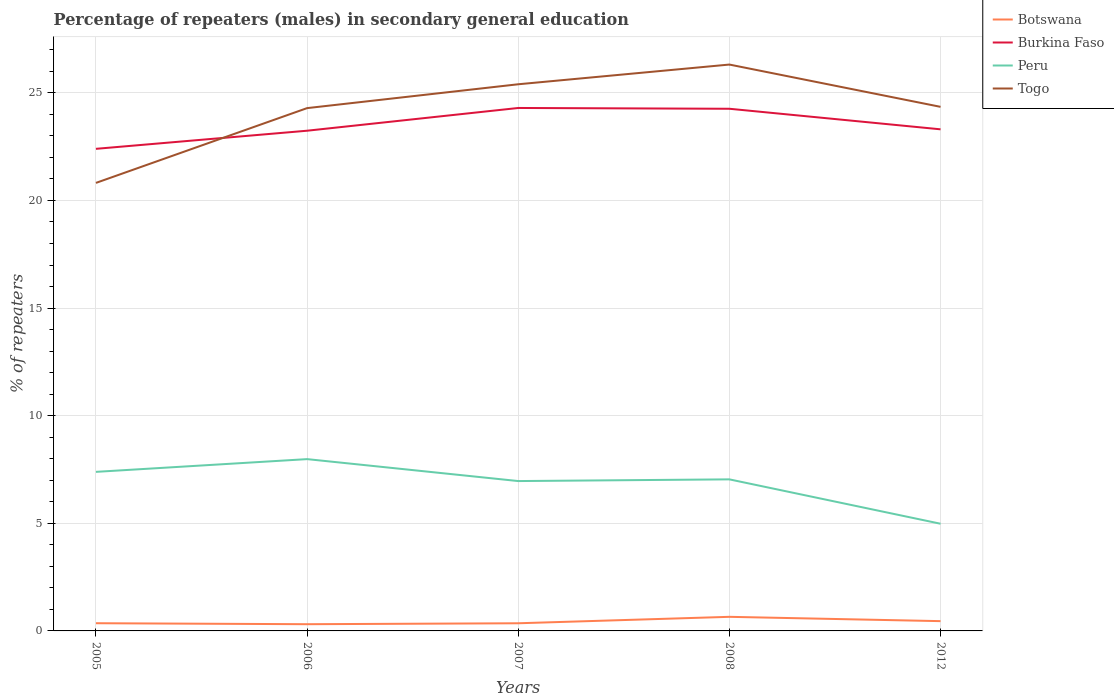Does the line corresponding to Botswana intersect with the line corresponding to Togo?
Offer a terse response. No. Is the number of lines equal to the number of legend labels?
Keep it short and to the point. Yes. Across all years, what is the maximum percentage of male repeaters in Burkina Faso?
Keep it short and to the point. 22.4. What is the total percentage of male repeaters in Togo in the graph?
Ensure brevity in your answer.  -3.53. What is the difference between the highest and the second highest percentage of male repeaters in Burkina Faso?
Provide a succinct answer. 1.9. What is the difference between the highest and the lowest percentage of male repeaters in Togo?
Provide a succinct answer. 4. How many years are there in the graph?
Provide a succinct answer. 5. Does the graph contain any zero values?
Ensure brevity in your answer.  No. What is the title of the graph?
Your answer should be very brief. Percentage of repeaters (males) in secondary general education. Does "Fragile and conflict affected situations" appear as one of the legend labels in the graph?
Give a very brief answer. No. What is the label or title of the X-axis?
Your response must be concise. Years. What is the label or title of the Y-axis?
Your answer should be very brief. % of repeaters. What is the % of repeaters of Botswana in 2005?
Provide a succinct answer. 0.36. What is the % of repeaters in Burkina Faso in 2005?
Make the answer very short. 22.4. What is the % of repeaters of Peru in 2005?
Ensure brevity in your answer.  7.39. What is the % of repeaters of Togo in 2005?
Keep it short and to the point. 20.82. What is the % of repeaters in Botswana in 2006?
Your answer should be compact. 0.31. What is the % of repeaters in Burkina Faso in 2006?
Your answer should be compact. 23.24. What is the % of repeaters in Peru in 2006?
Your response must be concise. 7.98. What is the % of repeaters in Togo in 2006?
Make the answer very short. 24.29. What is the % of repeaters of Botswana in 2007?
Your response must be concise. 0.36. What is the % of repeaters in Burkina Faso in 2007?
Make the answer very short. 24.3. What is the % of repeaters of Peru in 2007?
Make the answer very short. 6.96. What is the % of repeaters of Togo in 2007?
Offer a terse response. 25.4. What is the % of repeaters of Botswana in 2008?
Provide a succinct answer. 0.65. What is the % of repeaters in Burkina Faso in 2008?
Make the answer very short. 24.26. What is the % of repeaters in Peru in 2008?
Provide a succinct answer. 7.04. What is the % of repeaters of Togo in 2008?
Give a very brief answer. 26.31. What is the % of repeaters in Botswana in 2012?
Give a very brief answer. 0.45. What is the % of repeaters in Burkina Faso in 2012?
Your answer should be very brief. 23.3. What is the % of repeaters in Peru in 2012?
Give a very brief answer. 4.98. What is the % of repeaters of Togo in 2012?
Your response must be concise. 24.35. Across all years, what is the maximum % of repeaters in Botswana?
Provide a succinct answer. 0.65. Across all years, what is the maximum % of repeaters of Burkina Faso?
Ensure brevity in your answer.  24.3. Across all years, what is the maximum % of repeaters in Peru?
Your answer should be very brief. 7.98. Across all years, what is the maximum % of repeaters of Togo?
Make the answer very short. 26.31. Across all years, what is the minimum % of repeaters of Botswana?
Provide a succinct answer. 0.31. Across all years, what is the minimum % of repeaters in Burkina Faso?
Your answer should be compact. 22.4. Across all years, what is the minimum % of repeaters of Peru?
Your answer should be very brief. 4.98. Across all years, what is the minimum % of repeaters in Togo?
Offer a very short reply. 20.82. What is the total % of repeaters in Botswana in the graph?
Your response must be concise. 2.14. What is the total % of repeaters of Burkina Faso in the graph?
Keep it short and to the point. 117.5. What is the total % of repeaters in Peru in the graph?
Ensure brevity in your answer.  34.36. What is the total % of repeaters of Togo in the graph?
Offer a terse response. 121.17. What is the difference between the % of repeaters in Botswana in 2005 and that in 2006?
Your response must be concise. 0.05. What is the difference between the % of repeaters in Burkina Faso in 2005 and that in 2006?
Offer a terse response. -0.84. What is the difference between the % of repeaters in Peru in 2005 and that in 2006?
Your answer should be very brief. -0.59. What is the difference between the % of repeaters in Togo in 2005 and that in 2006?
Ensure brevity in your answer.  -3.47. What is the difference between the % of repeaters of Botswana in 2005 and that in 2007?
Provide a succinct answer. 0. What is the difference between the % of repeaters in Burkina Faso in 2005 and that in 2007?
Keep it short and to the point. -1.9. What is the difference between the % of repeaters in Peru in 2005 and that in 2007?
Your response must be concise. 0.43. What is the difference between the % of repeaters of Togo in 2005 and that in 2007?
Offer a terse response. -4.58. What is the difference between the % of repeaters of Botswana in 2005 and that in 2008?
Ensure brevity in your answer.  -0.3. What is the difference between the % of repeaters in Burkina Faso in 2005 and that in 2008?
Your response must be concise. -1.86. What is the difference between the % of repeaters in Peru in 2005 and that in 2008?
Your response must be concise. 0.35. What is the difference between the % of repeaters in Togo in 2005 and that in 2008?
Offer a very short reply. -5.5. What is the difference between the % of repeaters of Botswana in 2005 and that in 2012?
Offer a very short reply. -0.1. What is the difference between the % of repeaters in Burkina Faso in 2005 and that in 2012?
Offer a terse response. -0.91. What is the difference between the % of repeaters of Peru in 2005 and that in 2012?
Provide a short and direct response. 2.41. What is the difference between the % of repeaters of Togo in 2005 and that in 2012?
Provide a short and direct response. -3.53. What is the difference between the % of repeaters of Botswana in 2006 and that in 2007?
Your answer should be compact. -0.04. What is the difference between the % of repeaters in Burkina Faso in 2006 and that in 2007?
Provide a succinct answer. -1.06. What is the difference between the % of repeaters of Peru in 2006 and that in 2007?
Your answer should be very brief. 1.02. What is the difference between the % of repeaters of Togo in 2006 and that in 2007?
Ensure brevity in your answer.  -1.11. What is the difference between the % of repeaters in Botswana in 2006 and that in 2008?
Your response must be concise. -0.34. What is the difference between the % of repeaters of Burkina Faso in 2006 and that in 2008?
Ensure brevity in your answer.  -1.02. What is the difference between the % of repeaters of Peru in 2006 and that in 2008?
Make the answer very short. 0.94. What is the difference between the % of repeaters in Togo in 2006 and that in 2008?
Offer a terse response. -2.02. What is the difference between the % of repeaters of Botswana in 2006 and that in 2012?
Provide a succinct answer. -0.14. What is the difference between the % of repeaters in Burkina Faso in 2006 and that in 2012?
Keep it short and to the point. -0.06. What is the difference between the % of repeaters in Peru in 2006 and that in 2012?
Your answer should be compact. 3. What is the difference between the % of repeaters in Togo in 2006 and that in 2012?
Provide a short and direct response. -0.06. What is the difference between the % of repeaters of Botswana in 2007 and that in 2008?
Your response must be concise. -0.3. What is the difference between the % of repeaters of Burkina Faso in 2007 and that in 2008?
Ensure brevity in your answer.  0.04. What is the difference between the % of repeaters in Peru in 2007 and that in 2008?
Offer a very short reply. -0.08. What is the difference between the % of repeaters in Togo in 2007 and that in 2008?
Your response must be concise. -0.92. What is the difference between the % of repeaters of Botswana in 2007 and that in 2012?
Offer a terse response. -0.1. What is the difference between the % of repeaters in Burkina Faso in 2007 and that in 2012?
Offer a terse response. 0.99. What is the difference between the % of repeaters in Peru in 2007 and that in 2012?
Provide a short and direct response. 1.98. What is the difference between the % of repeaters in Togo in 2007 and that in 2012?
Make the answer very short. 1.05. What is the difference between the % of repeaters in Botswana in 2008 and that in 2012?
Your response must be concise. 0.2. What is the difference between the % of repeaters in Burkina Faso in 2008 and that in 2012?
Provide a succinct answer. 0.96. What is the difference between the % of repeaters in Peru in 2008 and that in 2012?
Provide a short and direct response. 2.06. What is the difference between the % of repeaters of Togo in 2008 and that in 2012?
Provide a short and direct response. 1.96. What is the difference between the % of repeaters of Botswana in 2005 and the % of repeaters of Burkina Faso in 2006?
Offer a very short reply. -22.88. What is the difference between the % of repeaters in Botswana in 2005 and the % of repeaters in Peru in 2006?
Your response must be concise. -7.62. What is the difference between the % of repeaters in Botswana in 2005 and the % of repeaters in Togo in 2006?
Your answer should be very brief. -23.93. What is the difference between the % of repeaters of Burkina Faso in 2005 and the % of repeaters of Peru in 2006?
Give a very brief answer. 14.42. What is the difference between the % of repeaters in Burkina Faso in 2005 and the % of repeaters in Togo in 2006?
Provide a succinct answer. -1.89. What is the difference between the % of repeaters in Peru in 2005 and the % of repeaters in Togo in 2006?
Give a very brief answer. -16.9. What is the difference between the % of repeaters of Botswana in 2005 and the % of repeaters of Burkina Faso in 2007?
Your answer should be compact. -23.94. What is the difference between the % of repeaters in Botswana in 2005 and the % of repeaters in Peru in 2007?
Make the answer very short. -6.6. What is the difference between the % of repeaters in Botswana in 2005 and the % of repeaters in Togo in 2007?
Your response must be concise. -25.04. What is the difference between the % of repeaters in Burkina Faso in 2005 and the % of repeaters in Peru in 2007?
Keep it short and to the point. 15.44. What is the difference between the % of repeaters of Burkina Faso in 2005 and the % of repeaters of Togo in 2007?
Your response must be concise. -3. What is the difference between the % of repeaters of Peru in 2005 and the % of repeaters of Togo in 2007?
Offer a very short reply. -18.01. What is the difference between the % of repeaters in Botswana in 2005 and the % of repeaters in Burkina Faso in 2008?
Keep it short and to the point. -23.9. What is the difference between the % of repeaters of Botswana in 2005 and the % of repeaters of Peru in 2008?
Give a very brief answer. -6.68. What is the difference between the % of repeaters in Botswana in 2005 and the % of repeaters in Togo in 2008?
Offer a terse response. -25.96. What is the difference between the % of repeaters of Burkina Faso in 2005 and the % of repeaters of Peru in 2008?
Your response must be concise. 15.36. What is the difference between the % of repeaters of Burkina Faso in 2005 and the % of repeaters of Togo in 2008?
Ensure brevity in your answer.  -3.92. What is the difference between the % of repeaters of Peru in 2005 and the % of repeaters of Togo in 2008?
Provide a succinct answer. -18.92. What is the difference between the % of repeaters of Botswana in 2005 and the % of repeaters of Burkina Faso in 2012?
Your answer should be very brief. -22.95. What is the difference between the % of repeaters in Botswana in 2005 and the % of repeaters in Peru in 2012?
Your response must be concise. -4.62. What is the difference between the % of repeaters in Botswana in 2005 and the % of repeaters in Togo in 2012?
Your answer should be compact. -23.99. What is the difference between the % of repeaters in Burkina Faso in 2005 and the % of repeaters in Peru in 2012?
Ensure brevity in your answer.  17.42. What is the difference between the % of repeaters in Burkina Faso in 2005 and the % of repeaters in Togo in 2012?
Keep it short and to the point. -1.95. What is the difference between the % of repeaters of Peru in 2005 and the % of repeaters of Togo in 2012?
Offer a terse response. -16.96. What is the difference between the % of repeaters in Botswana in 2006 and the % of repeaters in Burkina Faso in 2007?
Your answer should be compact. -23.98. What is the difference between the % of repeaters in Botswana in 2006 and the % of repeaters in Peru in 2007?
Your answer should be compact. -6.65. What is the difference between the % of repeaters of Botswana in 2006 and the % of repeaters of Togo in 2007?
Keep it short and to the point. -25.09. What is the difference between the % of repeaters in Burkina Faso in 2006 and the % of repeaters in Peru in 2007?
Offer a very short reply. 16.28. What is the difference between the % of repeaters in Burkina Faso in 2006 and the % of repeaters in Togo in 2007?
Provide a short and direct response. -2.16. What is the difference between the % of repeaters in Peru in 2006 and the % of repeaters in Togo in 2007?
Keep it short and to the point. -17.42. What is the difference between the % of repeaters of Botswana in 2006 and the % of repeaters of Burkina Faso in 2008?
Provide a succinct answer. -23.95. What is the difference between the % of repeaters of Botswana in 2006 and the % of repeaters of Peru in 2008?
Your answer should be very brief. -6.73. What is the difference between the % of repeaters in Botswana in 2006 and the % of repeaters in Togo in 2008?
Your response must be concise. -26. What is the difference between the % of repeaters of Burkina Faso in 2006 and the % of repeaters of Peru in 2008?
Provide a short and direct response. 16.2. What is the difference between the % of repeaters in Burkina Faso in 2006 and the % of repeaters in Togo in 2008?
Ensure brevity in your answer.  -3.07. What is the difference between the % of repeaters in Peru in 2006 and the % of repeaters in Togo in 2008?
Give a very brief answer. -18.33. What is the difference between the % of repeaters of Botswana in 2006 and the % of repeaters of Burkina Faso in 2012?
Offer a terse response. -22.99. What is the difference between the % of repeaters in Botswana in 2006 and the % of repeaters in Peru in 2012?
Keep it short and to the point. -4.67. What is the difference between the % of repeaters of Botswana in 2006 and the % of repeaters of Togo in 2012?
Make the answer very short. -24.04. What is the difference between the % of repeaters of Burkina Faso in 2006 and the % of repeaters of Peru in 2012?
Your answer should be compact. 18.26. What is the difference between the % of repeaters of Burkina Faso in 2006 and the % of repeaters of Togo in 2012?
Ensure brevity in your answer.  -1.11. What is the difference between the % of repeaters of Peru in 2006 and the % of repeaters of Togo in 2012?
Make the answer very short. -16.37. What is the difference between the % of repeaters in Botswana in 2007 and the % of repeaters in Burkina Faso in 2008?
Provide a succinct answer. -23.9. What is the difference between the % of repeaters in Botswana in 2007 and the % of repeaters in Peru in 2008?
Give a very brief answer. -6.69. What is the difference between the % of repeaters of Botswana in 2007 and the % of repeaters of Togo in 2008?
Your answer should be very brief. -25.96. What is the difference between the % of repeaters in Burkina Faso in 2007 and the % of repeaters in Peru in 2008?
Give a very brief answer. 17.25. What is the difference between the % of repeaters of Burkina Faso in 2007 and the % of repeaters of Togo in 2008?
Offer a very short reply. -2.02. What is the difference between the % of repeaters of Peru in 2007 and the % of repeaters of Togo in 2008?
Your answer should be compact. -19.35. What is the difference between the % of repeaters in Botswana in 2007 and the % of repeaters in Burkina Faso in 2012?
Your answer should be compact. -22.95. What is the difference between the % of repeaters of Botswana in 2007 and the % of repeaters of Peru in 2012?
Ensure brevity in your answer.  -4.62. What is the difference between the % of repeaters of Botswana in 2007 and the % of repeaters of Togo in 2012?
Offer a terse response. -23.99. What is the difference between the % of repeaters of Burkina Faso in 2007 and the % of repeaters of Peru in 2012?
Your response must be concise. 19.32. What is the difference between the % of repeaters in Burkina Faso in 2007 and the % of repeaters in Togo in 2012?
Offer a terse response. -0.05. What is the difference between the % of repeaters of Peru in 2007 and the % of repeaters of Togo in 2012?
Provide a short and direct response. -17.39. What is the difference between the % of repeaters in Botswana in 2008 and the % of repeaters in Burkina Faso in 2012?
Offer a very short reply. -22.65. What is the difference between the % of repeaters of Botswana in 2008 and the % of repeaters of Peru in 2012?
Your answer should be compact. -4.32. What is the difference between the % of repeaters of Botswana in 2008 and the % of repeaters of Togo in 2012?
Your answer should be very brief. -23.69. What is the difference between the % of repeaters of Burkina Faso in 2008 and the % of repeaters of Peru in 2012?
Make the answer very short. 19.28. What is the difference between the % of repeaters of Burkina Faso in 2008 and the % of repeaters of Togo in 2012?
Your response must be concise. -0.09. What is the difference between the % of repeaters in Peru in 2008 and the % of repeaters in Togo in 2012?
Your response must be concise. -17.31. What is the average % of repeaters of Botswana per year?
Provide a short and direct response. 0.43. What is the average % of repeaters of Burkina Faso per year?
Give a very brief answer. 23.5. What is the average % of repeaters in Peru per year?
Offer a terse response. 6.87. What is the average % of repeaters of Togo per year?
Make the answer very short. 24.23. In the year 2005, what is the difference between the % of repeaters in Botswana and % of repeaters in Burkina Faso?
Ensure brevity in your answer.  -22.04. In the year 2005, what is the difference between the % of repeaters in Botswana and % of repeaters in Peru?
Provide a short and direct response. -7.03. In the year 2005, what is the difference between the % of repeaters in Botswana and % of repeaters in Togo?
Your answer should be very brief. -20.46. In the year 2005, what is the difference between the % of repeaters in Burkina Faso and % of repeaters in Peru?
Offer a very short reply. 15.01. In the year 2005, what is the difference between the % of repeaters in Burkina Faso and % of repeaters in Togo?
Make the answer very short. 1.58. In the year 2005, what is the difference between the % of repeaters of Peru and % of repeaters of Togo?
Keep it short and to the point. -13.43. In the year 2006, what is the difference between the % of repeaters in Botswana and % of repeaters in Burkina Faso?
Give a very brief answer. -22.93. In the year 2006, what is the difference between the % of repeaters of Botswana and % of repeaters of Peru?
Your answer should be compact. -7.67. In the year 2006, what is the difference between the % of repeaters in Botswana and % of repeaters in Togo?
Ensure brevity in your answer.  -23.98. In the year 2006, what is the difference between the % of repeaters of Burkina Faso and % of repeaters of Peru?
Give a very brief answer. 15.26. In the year 2006, what is the difference between the % of repeaters in Burkina Faso and % of repeaters in Togo?
Your answer should be very brief. -1.05. In the year 2006, what is the difference between the % of repeaters in Peru and % of repeaters in Togo?
Ensure brevity in your answer.  -16.31. In the year 2007, what is the difference between the % of repeaters of Botswana and % of repeaters of Burkina Faso?
Provide a succinct answer. -23.94. In the year 2007, what is the difference between the % of repeaters of Botswana and % of repeaters of Peru?
Your answer should be compact. -6.61. In the year 2007, what is the difference between the % of repeaters of Botswana and % of repeaters of Togo?
Give a very brief answer. -25.04. In the year 2007, what is the difference between the % of repeaters in Burkina Faso and % of repeaters in Peru?
Give a very brief answer. 17.33. In the year 2007, what is the difference between the % of repeaters of Burkina Faso and % of repeaters of Togo?
Your answer should be very brief. -1.1. In the year 2007, what is the difference between the % of repeaters in Peru and % of repeaters in Togo?
Your response must be concise. -18.44. In the year 2008, what is the difference between the % of repeaters in Botswana and % of repeaters in Burkina Faso?
Provide a short and direct response. -23.61. In the year 2008, what is the difference between the % of repeaters of Botswana and % of repeaters of Peru?
Keep it short and to the point. -6.39. In the year 2008, what is the difference between the % of repeaters of Botswana and % of repeaters of Togo?
Ensure brevity in your answer.  -25.66. In the year 2008, what is the difference between the % of repeaters in Burkina Faso and % of repeaters in Peru?
Make the answer very short. 17.22. In the year 2008, what is the difference between the % of repeaters in Burkina Faso and % of repeaters in Togo?
Give a very brief answer. -2.05. In the year 2008, what is the difference between the % of repeaters in Peru and % of repeaters in Togo?
Offer a very short reply. -19.27. In the year 2012, what is the difference between the % of repeaters of Botswana and % of repeaters of Burkina Faso?
Provide a succinct answer. -22.85. In the year 2012, what is the difference between the % of repeaters of Botswana and % of repeaters of Peru?
Keep it short and to the point. -4.53. In the year 2012, what is the difference between the % of repeaters of Botswana and % of repeaters of Togo?
Offer a terse response. -23.89. In the year 2012, what is the difference between the % of repeaters of Burkina Faso and % of repeaters of Peru?
Your response must be concise. 18.32. In the year 2012, what is the difference between the % of repeaters of Burkina Faso and % of repeaters of Togo?
Your answer should be very brief. -1.04. In the year 2012, what is the difference between the % of repeaters of Peru and % of repeaters of Togo?
Provide a succinct answer. -19.37. What is the ratio of the % of repeaters of Botswana in 2005 to that in 2006?
Provide a short and direct response. 1.15. What is the ratio of the % of repeaters of Burkina Faso in 2005 to that in 2006?
Ensure brevity in your answer.  0.96. What is the ratio of the % of repeaters in Peru in 2005 to that in 2006?
Ensure brevity in your answer.  0.93. What is the ratio of the % of repeaters in Togo in 2005 to that in 2006?
Ensure brevity in your answer.  0.86. What is the ratio of the % of repeaters in Botswana in 2005 to that in 2007?
Provide a short and direct response. 1.01. What is the ratio of the % of repeaters in Burkina Faso in 2005 to that in 2007?
Offer a very short reply. 0.92. What is the ratio of the % of repeaters in Peru in 2005 to that in 2007?
Provide a succinct answer. 1.06. What is the ratio of the % of repeaters in Togo in 2005 to that in 2007?
Your answer should be very brief. 0.82. What is the ratio of the % of repeaters in Botswana in 2005 to that in 2008?
Offer a very short reply. 0.55. What is the ratio of the % of repeaters in Burkina Faso in 2005 to that in 2008?
Your response must be concise. 0.92. What is the ratio of the % of repeaters of Peru in 2005 to that in 2008?
Provide a short and direct response. 1.05. What is the ratio of the % of repeaters of Togo in 2005 to that in 2008?
Provide a short and direct response. 0.79. What is the ratio of the % of repeaters of Botswana in 2005 to that in 2012?
Offer a terse response. 0.79. What is the ratio of the % of repeaters of Burkina Faso in 2005 to that in 2012?
Provide a short and direct response. 0.96. What is the ratio of the % of repeaters in Peru in 2005 to that in 2012?
Give a very brief answer. 1.48. What is the ratio of the % of repeaters of Togo in 2005 to that in 2012?
Provide a succinct answer. 0.85. What is the ratio of the % of repeaters in Botswana in 2006 to that in 2007?
Your answer should be compact. 0.88. What is the ratio of the % of repeaters in Burkina Faso in 2006 to that in 2007?
Give a very brief answer. 0.96. What is the ratio of the % of repeaters of Peru in 2006 to that in 2007?
Your answer should be very brief. 1.15. What is the ratio of the % of repeaters in Togo in 2006 to that in 2007?
Make the answer very short. 0.96. What is the ratio of the % of repeaters in Botswana in 2006 to that in 2008?
Your response must be concise. 0.48. What is the ratio of the % of repeaters in Burkina Faso in 2006 to that in 2008?
Offer a terse response. 0.96. What is the ratio of the % of repeaters of Peru in 2006 to that in 2008?
Offer a terse response. 1.13. What is the ratio of the % of repeaters of Togo in 2006 to that in 2008?
Make the answer very short. 0.92. What is the ratio of the % of repeaters of Botswana in 2006 to that in 2012?
Offer a very short reply. 0.69. What is the ratio of the % of repeaters of Peru in 2006 to that in 2012?
Your answer should be compact. 1.6. What is the ratio of the % of repeaters of Botswana in 2007 to that in 2008?
Give a very brief answer. 0.54. What is the ratio of the % of repeaters of Togo in 2007 to that in 2008?
Your response must be concise. 0.97. What is the ratio of the % of repeaters in Botswana in 2007 to that in 2012?
Make the answer very short. 0.78. What is the ratio of the % of repeaters in Burkina Faso in 2007 to that in 2012?
Keep it short and to the point. 1.04. What is the ratio of the % of repeaters of Peru in 2007 to that in 2012?
Provide a succinct answer. 1.4. What is the ratio of the % of repeaters of Togo in 2007 to that in 2012?
Your response must be concise. 1.04. What is the ratio of the % of repeaters of Botswana in 2008 to that in 2012?
Your answer should be compact. 1.44. What is the ratio of the % of repeaters of Burkina Faso in 2008 to that in 2012?
Ensure brevity in your answer.  1.04. What is the ratio of the % of repeaters of Peru in 2008 to that in 2012?
Keep it short and to the point. 1.41. What is the ratio of the % of repeaters in Togo in 2008 to that in 2012?
Your response must be concise. 1.08. What is the difference between the highest and the second highest % of repeaters of Botswana?
Your answer should be compact. 0.2. What is the difference between the highest and the second highest % of repeaters of Burkina Faso?
Give a very brief answer. 0.04. What is the difference between the highest and the second highest % of repeaters in Peru?
Your answer should be compact. 0.59. What is the difference between the highest and the second highest % of repeaters in Togo?
Your response must be concise. 0.92. What is the difference between the highest and the lowest % of repeaters in Botswana?
Offer a terse response. 0.34. What is the difference between the highest and the lowest % of repeaters of Burkina Faso?
Offer a terse response. 1.9. What is the difference between the highest and the lowest % of repeaters of Peru?
Your answer should be very brief. 3. What is the difference between the highest and the lowest % of repeaters of Togo?
Offer a terse response. 5.5. 